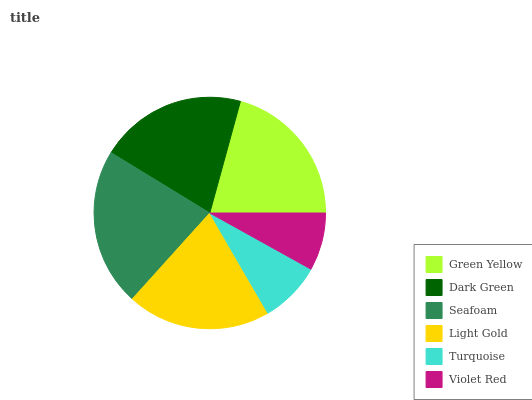Is Violet Red the minimum?
Answer yes or no. Yes. Is Seafoam the maximum?
Answer yes or no. Yes. Is Dark Green the minimum?
Answer yes or no. No. Is Dark Green the maximum?
Answer yes or no. No. Is Green Yellow greater than Dark Green?
Answer yes or no. Yes. Is Dark Green less than Green Yellow?
Answer yes or no. Yes. Is Dark Green greater than Green Yellow?
Answer yes or no. No. Is Green Yellow less than Dark Green?
Answer yes or no. No. Is Dark Green the high median?
Answer yes or no. Yes. Is Light Gold the low median?
Answer yes or no. Yes. Is Seafoam the high median?
Answer yes or no. No. Is Seafoam the low median?
Answer yes or no. No. 